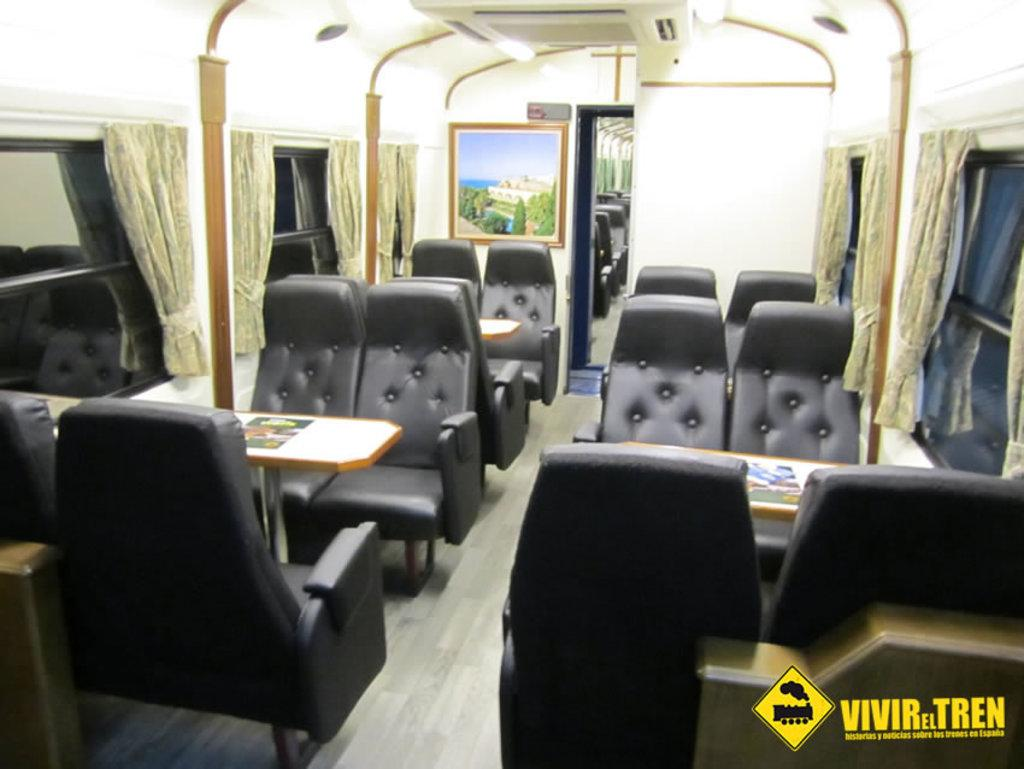What color are the seats in the image? The seats in the image are black. What type of furniture is present in the image besides the seats? There are tables in the image. What type of window treatment is visible in the image? There are curtains on a window in the image. What is hanging on the wall in the image? There is a photo frame on a wall in the image. What type of list can be seen on the wall in the image? There is no list present on the wall in the image; only a photo frame is visible. 